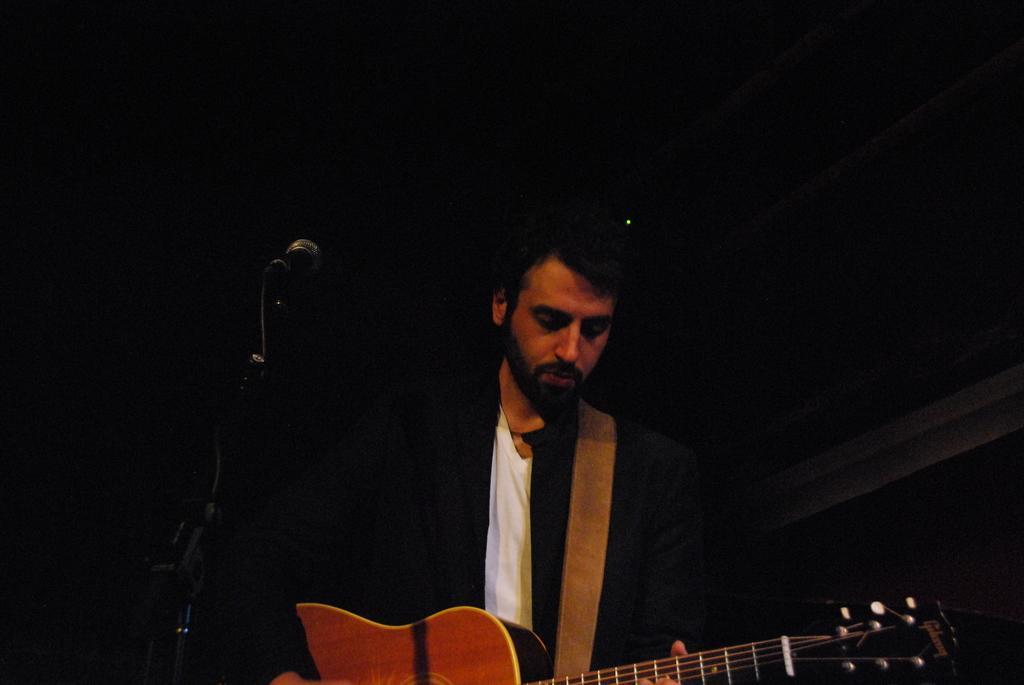Can you describe this image briefly? In the middle of the image a man is standing and holding a guitar. Bottom left side of the image there is a microphone. 